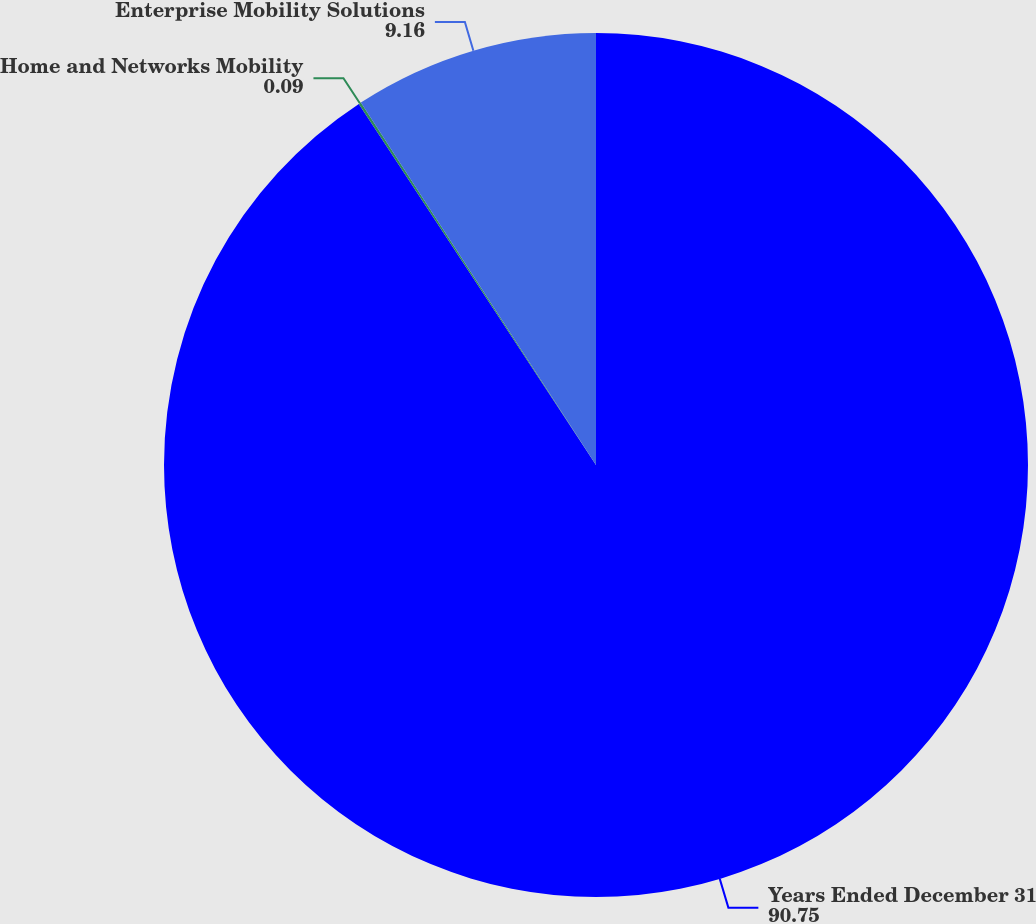Convert chart. <chart><loc_0><loc_0><loc_500><loc_500><pie_chart><fcel>Years Ended December 31<fcel>Home and Networks Mobility<fcel>Enterprise Mobility Solutions<nl><fcel>90.75%<fcel>0.09%<fcel>9.16%<nl></chart> 